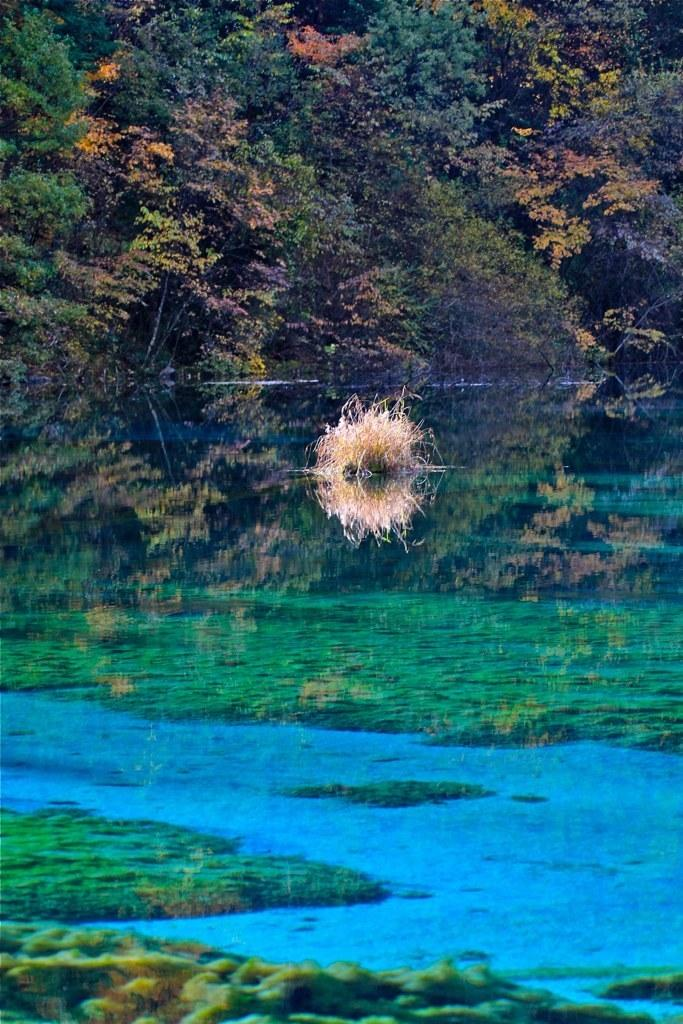Where was the picture taken? The picture was clicked outside the city. What can be seen in the center of the image? There is an object in the water body in the center of the image. What type of natural environment is visible in the background of the image? There are trees visible in the background of the image. Is there any quicksand visible in the image? There is no quicksand present in the image. Can you see a pig in the water body in the image? There is no pig visible in the image. 